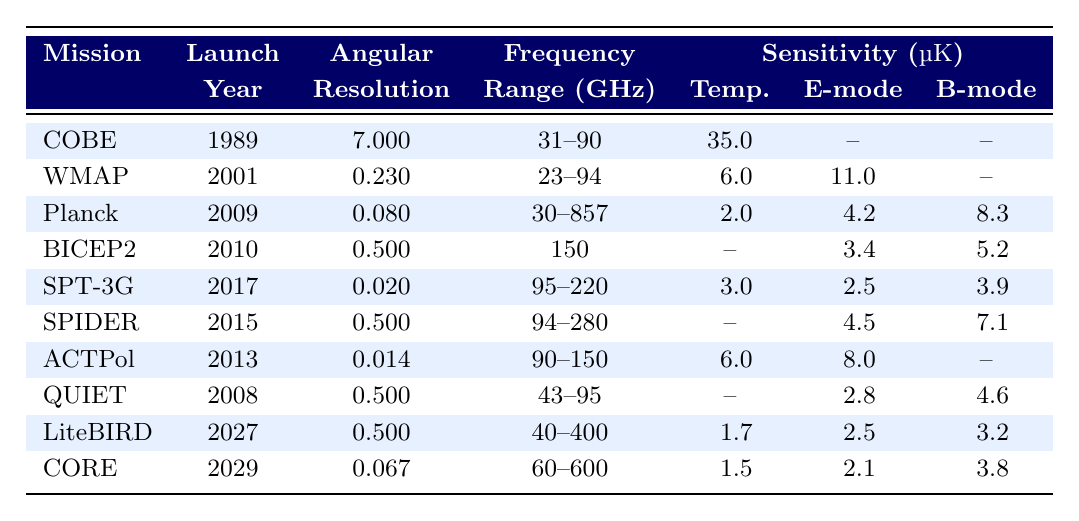What is the launch year of the Planck mission? The table directly lists the launch year for the Planck mission, which is in the column labeled "Launch Year." Since Planck is listed in the third row, I can see that its launch year is 2009.
Answer: 2009 Which mission has the highest angular resolution? To find the highest angular resolution, I can compare the "Angular Resolution" values in the table. The highest value is found in the mission ACTPol at 0.014.
Answer: ACTPol What is the temperature sensitivity of SPT-3G? The temperature sensitivity for the SPT-3G mission is found in the column labeled "Temperature Sensitivity." Looking at the corresponding row, the value is 3 μK.
Answer: 3 μK Does the BICEP2 mission have any temperature sensitivity reported? In the BICEP2 row, under "Temperature Sensitivity," the value is not provided (it is marked as null). Therefore, it indicates there is no temperature sensitivity reported.
Answer: No What is the average temperature sensitivity of missions that have a reported temperature sensitivity value? To find the average, I first sum the reported temperature sensitivities: 35 (COBE) + 6 (WMAP) + 2 (Planck) + 3 (SPT-3G) + 1.7 (LiteBIRD) + 1.5 (CORE) = 49.2. Next, I count the number of missions with reported temperature sensitivities, which is 6. So, the average is 49.2 / 6 = 8.2 μK.
Answer: 8.2 μK Which mission has the lowest frequency range? I can look down the "Frequency Range" column to find the mission with the lowest range. The BICEP2 mission has a frequency range of 150 GHz, which is the lowest specified frequency range in the table.
Answer: BICEP2 What is the difference in E-mode polarization sensitivity between WMAP and Planck? I can compare the E-mode polarization sensitivity values from both missions. WMAP's E-mode sensitivity is 11 μK, while Planck's is 4.2 μK. The difference is calculated as 11 - 4.2 = 6.8 μK.
Answer: 6.8 μK Is there any mission that has no reported B-mode polarization sensitivity? To determine this, I look at the "B-mode Polarization Sensitivity" column. Both COBE and WMAP show null entries for their B-mode sensitivity. Thus, yes, there are missions without reported B-mode sensitivity.
Answer: Yes Which mission has the best E-mode polarization sensitivity and what is the value? Scanning through the E-mode polarization sensitivity values, the highest sensitivity is found with WMAP at 11 μK. This is the best among all missions listed.
Answer: WMAP, 11 μK What is the relationship between the launch year and the angular resolution of the missions? I analyze the table to see if there's a trend or correlation. Generally, more recent missions (like Planck and LiteBIRD) have lower angular resolutions than older missions like COBE that has a higher resolution value of 7. This suggests that newer missions are utilizing more advanced technology which allows for higher performance despite lower angular resolution numbers.
Answer: Recent missions have lower angular resolution values 